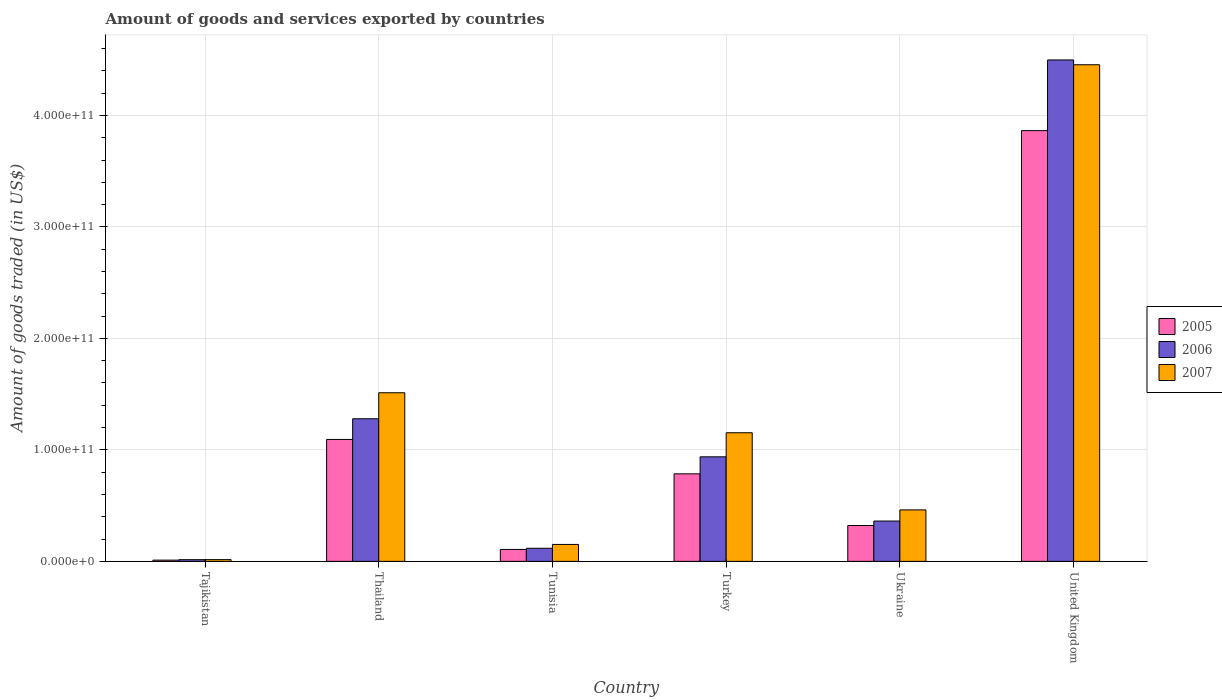How many different coloured bars are there?
Give a very brief answer. 3. How many groups of bars are there?
Keep it short and to the point. 6. Are the number of bars per tick equal to the number of legend labels?
Ensure brevity in your answer.  Yes. Are the number of bars on each tick of the X-axis equal?
Provide a succinct answer. Yes. What is the label of the 5th group of bars from the left?
Provide a short and direct response. Ukraine. In how many cases, is the number of bars for a given country not equal to the number of legend labels?
Make the answer very short. 0. What is the total amount of goods and services exported in 2005 in Tunisia?
Your answer should be compact. 1.07e+1. Across all countries, what is the maximum total amount of goods and services exported in 2007?
Your response must be concise. 4.45e+11. Across all countries, what is the minimum total amount of goods and services exported in 2005?
Offer a terse response. 1.11e+09. In which country was the total amount of goods and services exported in 2005 minimum?
Provide a succinct answer. Tajikistan. What is the total total amount of goods and services exported in 2006 in the graph?
Ensure brevity in your answer.  7.21e+11. What is the difference between the total amount of goods and services exported in 2007 in Turkey and that in United Kingdom?
Make the answer very short. -3.30e+11. What is the difference between the total amount of goods and services exported in 2006 in Thailand and the total amount of goods and services exported in 2007 in Turkey?
Keep it short and to the point. 1.26e+1. What is the average total amount of goods and services exported in 2005 per country?
Make the answer very short. 1.03e+11. What is the difference between the total amount of goods and services exported of/in 2006 and total amount of goods and services exported of/in 2005 in Turkey?
Provide a short and direct response. 1.53e+1. What is the ratio of the total amount of goods and services exported in 2005 in Tajikistan to that in Ukraine?
Your answer should be very brief. 0.03. Is the difference between the total amount of goods and services exported in 2006 in Thailand and Tunisia greater than the difference between the total amount of goods and services exported in 2005 in Thailand and Tunisia?
Offer a terse response. Yes. What is the difference between the highest and the second highest total amount of goods and services exported in 2005?
Ensure brevity in your answer.  3.08e+11. What is the difference between the highest and the lowest total amount of goods and services exported in 2005?
Keep it short and to the point. 3.85e+11. In how many countries, is the total amount of goods and services exported in 2005 greater than the average total amount of goods and services exported in 2005 taken over all countries?
Keep it short and to the point. 2. What does the 2nd bar from the left in Ukraine represents?
Give a very brief answer. 2006. What does the 3rd bar from the right in United Kingdom represents?
Ensure brevity in your answer.  2005. How many countries are there in the graph?
Your response must be concise. 6. What is the difference between two consecutive major ticks on the Y-axis?
Your answer should be very brief. 1.00e+11. Does the graph contain grids?
Give a very brief answer. Yes. How are the legend labels stacked?
Offer a terse response. Vertical. What is the title of the graph?
Your answer should be very brief. Amount of goods and services exported by countries. What is the label or title of the Y-axis?
Give a very brief answer. Amount of goods traded (in US$). What is the Amount of goods traded (in US$) of 2005 in Tajikistan?
Provide a succinct answer. 1.11e+09. What is the Amount of goods traded (in US$) of 2006 in Tajikistan?
Your answer should be very brief. 1.51e+09. What is the Amount of goods traded (in US$) in 2007 in Tajikistan?
Provide a short and direct response. 1.56e+09. What is the Amount of goods traded (in US$) in 2005 in Thailand?
Your answer should be very brief. 1.09e+11. What is the Amount of goods traded (in US$) of 2006 in Thailand?
Offer a very short reply. 1.28e+11. What is the Amount of goods traded (in US$) in 2007 in Thailand?
Ensure brevity in your answer.  1.51e+11. What is the Amount of goods traded (in US$) of 2005 in Tunisia?
Offer a terse response. 1.07e+1. What is the Amount of goods traded (in US$) in 2006 in Tunisia?
Make the answer very short. 1.17e+1. What is the Amount of goods traded (in US$) of 2007 in Tunisia?
Give a very brief answer. 1.52e+1. What is the Amount of goods traded (in US$) of 2005 in Turkey?
Provide a succinct answer. 7.85e+1. What is the Amount of goods traded (in US$) of 2006 in Turkey?
Keep it short and to the point. 9.38e+1. What is the Amount of goods traded (in US$) of 2007 in Turkey?
Provide a short and direct response. 1.15e+11. What is the Amount of goods traded (in US$) in 2005 in Ukraine?
Offer a very short reply. 3.22e+1. What is the Amount of goods traded (in US$) in 2006 in Ukraine?
Your response must be concise. 3.62e+1. What is the Amount of goods traded (in US$) of 2007 in Ukraine?
Offer a terse response. 4.62e+1. What is the Amount of goods traded (in US$) of 2005 in United Kingdom?
Make the answer very short. 3.86e+11. What is the Amount of goods traded (in US$) of 2006 in United Kingdom?
Keep it short and to the point. 4.50e+11. What is the Amount of goods traded (in US$) of 2007 in United Kingdom?
Offer a terse response. 4.45e+11. Across all countries, what is the maximum Amount of goods traded (in US$) in 2005?
Your response must be concise. 3.86e+11. Across all countries, what is the maximum Amount of goods traded (in US$) of 2006?
Your response must be concise. 4.50e+11. Across all countries, what is the maximum Amount of goods traded (in US$) of 2007?
Provide a short and direct response. 4.45e+11. Across all countries, what is the minimum Amount of goods traded (in US$) of 2005?
Provide a succinct answer. 1.11e+09. Across all countries, what is the minimum Amount of goods traded (in US$) of 2006?
Keep it short and to the point. 1.51e+09. Across all countries, what is the minimum Amount of goods traded (in US$) of 2007?
Make the answer very short. 1.56e+09. What is the total Amount of goods traded (in US$) in 2005 in the graph?
Your response must be concise. 6.18e+11. What is the total Amount of goods traded (in US$) of 2006 in the graph?
Provide a succinct answer. 7.21e+11. What is the total Amount of goods traded (in US$) of 2007 in the graph?
Ensure brevity in your answer.  7.75e+11. What is the difference between the Amount of goods traded (in US$) of 2005 in Tajikistan and that in Thailand?
Make the answer very short. -1.08e+11. What is the difference between the Amount of goods traded (in US$) of 2006 in Tajikistan and that in Thailand?
Provide a short and direct response. -1.26e+11. What is the difference between the Amount of goods traded (in US$) of 2007 in Tajikistan and that in Thailand?
Your response must be concise. -1.50e+11. What is the difference between the Amount of goods traded (in US$) of 2005 in Tajikistan and that in Tunisia?
Your answer should be compact. -9.58e+09. What is the difference between the Amount of goods traded (in US$) in 2006 in Tajikistan and that in Tunisia?
Your answer should be very brief. -1.02e+1. What is the difference between the Amount of goods traded (in US$) of 2007 in Tajikistan and that in Tunisia?
Your answer should be very brief. -1.36e+1. What is the difference between the Amount of goods traded (in US$) of 2005 in Tajikistan and that in Turkey?
Make the answer very short. -7.74e+1. What is the difference between the Amount of goods traded (in US$) in 2006 in Tajikistan and that in Turkey?
Your response must be concise. -9.23e+1. What is the difference between the Amount of goods traded (in US$) of 2007 in Tajikistan and that in Turkey?
Make the answer very short. -1.14e+11. What is the difference between the Amount of goods traded (in US$) of 2005 in Tajikistan and that in Ukraine?
Give a very brief answer. -3.11e+1. What is the difference between the Amount of goods traded (in US$) in 2006 in Tajikistan and that in Ukraine?
Make the answer very short. -3.47e+1. What is the difference between the Amount of goods traded (in US$) in 2007 in Tajikistan and that in Ukraine?
Provide a succinct answer. -4.46e+1. What is the difference between the Amount of goods traded (in US$) in 2005 in Tajikistan and that in United Kingdom?
Ensure brevity in your answer.  -3.85e+11. What is the difference between the Amount of goods traded (in US$) of 2006 in Tajikistan and that in United Kingdom?
Your answer should be compact. -4.48e+11. What is the difference between the Amount of goods traded (in US$) in 2007 in Tajikistan and that in United Kingdom?
Make the answer very short. -4.44e+11. What is the difference between the Amount of goods traded (in US$) in 2005 in Thailand and that in Tunisia?
Your answer should be compact. 9.87e+1. What is the difference between the Amount of goods traded (in US$) of 2006 in Thailand and that in Tunisia?
Provide a succinct answer. 1.16e+11. What is the difference between the Amount of goods traded (in US$) of 2007 in Thailand and that in Tunisia?
Ensure brevity in your answer.  1.36e+11. What is the difference between the Amount of goods traded (in US$) of 2005 in Thailand and that in Turkey?
Your answer should be very brief. 3.09e+1. What is the difference between the Amount of goods traded (in US$) in 2006 in Thailand and that in Turkey?
Offer a very short reply. 3.42e+1. What is the difference between the Amount of goods traded (in US$) in 2007 in Thailand and that in Turkey?
Your response must be concise. 3.59e+1. What is the difference between the Amount of goods traded (in US$) of 2005 in Thailand and that in Ukraine?
Your answer should be very brief. 7.72e+1. What is the difference between the Amount of goods traded (in US$) in 2006 in Thailand and that in Ukraine?
Provide a short and direct response. 9.18e+1. What is the difference between the Amount of goods traded (in US$) of 2007 in Thailand and that in Ukraine?
Make the answer very short. 1.05e+11. What is the difference between the Amount of goods traded (in US$) in 2005 in Thailand and that in United Kingdom?
Offer a terse response. -2.77e+11. What is the difference between the Amount of goods traded (in US$) of 2006 in Thailand and that in United Kingdom?
Keep it short and to the point. -3.22e+11. What is the difference between the Amount of goods traded (in US$) in 2007 in Thailand and that in United Kingdom?
Provide a succinct answer. -2.94e+11. What is the difference between the Amount of goods traded (in US$) of 2005 in Tunisia and that in Turkey?
Your response must be concise. -6.78e+1. What is the difference between the Amount of goods traded (in US$) in 2006 in Tunisia and that in Turkey?
Provide a short and direct response. -8.20e+1. What is the difference between the Amount of goods traded (in US$) of 2007 in Tunisia and that in Turkey?
Offer a very short reply. -1.00e+11. What is the difference between the Amount of goods traded (in US$) in 2005 in Tunisia and that in Ukraine?
Your answer should be compact. -2.15e+1. What is the difference between the Amount of goods traded (in US$) in 2006 in Tunisia and that in Ukraine?
Give a very brief answer. -2.44e+1. What is the difference between the Amount of goods traded (in US$) of 2007 in Tunisia and that in Ukraine?
Give a very brief answer. -3.10e+1. What is the difference between the Amount of goods traded (in US$) of 2005 in Tunisia and that in United Kingdom?
Make the answer very short. -3.76e+11. What is the difference between the Amount of goods traded (in US$) in 2006 in Tunisia and that in United Kingdom?
Provide a succinct answer. -4.38e+11. What is the difference between the Amount of goods traded (in US$) of 2007 in Tunisia and that in United Kingdom?
Make the answer very short. -4.30e+11. What is the difference between the Amount of goods traded (in US$) of 2005 in Turkey and that in Ukraine?
Ensure brevity in your answer.  4.63e+1. What is the difference between the Amount of goods traded (in US$) of 2006 in Turkey and that in Ukraine?
Your answer should be very brief. 5.76e+1. What is the difference between the Amount of goods traded (in US$) of 2007 in Turkey and that in Ukraine?
Give a very brief answer. 6.92e+1. What is the difference between the Amount of goods traded (in US$) in 2005 in Turkey and that in United Kingdom?
Provide a short and direct response. -3.08e+11. What is the difference between the Amount of goods traded (in US$) of 2006 in Turkey and that in United Kingdom?
Provide a succinct answer. -3.56e+11. What is the difference between the Amount of goods traded (in US$) in 2007 in Turkey and that in United Kingdom?
Provide a short and direct response. -3.30e+11. What is the difference between the Amount of goods traded (in US$) in 2005 in Ukraine and that in United Kingdom?
Provide a short and direct response. -3.54e+11. What is the difference between the Amount of goods traded (in US$) of 2006 in Ukraine and that in United Kingdom?
Ensure brevity in your answer.  -4.14e+11. What is the difference between the Amount of goods traded (in US$) of 2007 in Ukraine and that in United Kingdom?
Make the answer very short. -3.99e+11. What is the difference between the Amount of goods traded (in US$) in 2005 in Tajikistan and the Amount of goods traded (in US$) in 2006 in Thailand?
Offer a terse response. -1.27e+11. What is the difference between the Amount of goods traded (in US$) in 2005 in Tajikistan and the Amount of goods traded (in US$) in 2007 in Thailand?
Keep it short and to the point. -1.50e+11. What is the difference between the Amount of goods traded (in US$) in 2006 in Tajikistan and the Amount of goods traded (in US$) in 2007 in Thailand?
Make the answer very short. -1.50e+11. What is the difference between the Amount of goods traded (in US$) in 2005 in Tajikistan and the Amount of goods traded (in US$) in 2006 in Tunisia?
Keep it short and to the point. -1.06e+1. What is the difference between the Amount of goods traded (in US$) in 2005 in Tajikistan and the Amount of goods traded (in US$) in 2007 in Tunisia?
Your answer should be very brief. -1.41e+1. What is the difference between the Amount of goods traded (in US$) of 2006 in Tajikistan and the Amount of goods traded (in US$) of 2007 in Tunisia?
Give a very brief answer. -1.37e+1. What is the difference between the Amount of goods traded (in US$) in 2005 in Tajikistan and the Amount of goods traded (in US$) in 2006 in Turkey?
Provide a short and direct response. -9.27e+1. What is the difference between the Amount of goods traded (in US$) of 2005 in Tajikistan and the Amount of goods traded (in US$) of 2007 in Turkey?
Keep it short and to the point. -1.14e+11. What is the difference between the Amount of goods traded (in US$) of 2006 in Tajikistan and the Amount of goods traded (in US$) of 2007 in Turkey?
Provide a succinct answer. -1.14e+11. What is the difference between the Amount of goods traded (in US$) of 2005 in Tajikistan and the Amount of goods traded (in US$) of 2006 in Ukraine?
Provide a succinct answer. -3.51e+1. What is the difference between the Amount of goods traded (in US$) in 2005 in Tajikistan and the Amount of goods traded (in US$) in 2007 in Ukraine?
Keep it short and to the point. -4.51e+1. What is the difference between the Amount of goods traded (in US$) in 2006 in Tajikistan and the Amount of goods traded (in US$) in 2007 in Ukraine?
Give a very brief answer. -4.47e+1. What is the difference between the Amount of goods traded (in US$) in 2005 in Tajikistan and the Amount of goods traded (in US$) in 2006 in United Kingdom?
Offer a very short reply. -4.49e+11. What is the difference between the Amount of goods traded (in US$) of 2005 in Tajikistan and the Amount of goods traded (in US$) of 2007 in United Kingdom?
Provide a short and direct response. -4.44e+11. What is the difference between the Amount of goods traded (in US$) of 2006 in Tajikistan and the Amount of goods traded (in US$) of 2007 in United Kingdom?
Offer a very short reply. -4.44e+11. What is the difference between the Amount of goods traded (in US$) of 2005 in Thailand and the Amount of goods traded (in US$) of 2006 in Tunisia?
Offer a very short reply. 9.76e+1. What is the difference between the Amount of goods traded (in US$) in 2005 in Thailand and the Amount of goods traded (in US$) in 2007 in Tunisia?
Provide a succinct answer. 9.42e+1. What is the difference between the Amount of goods traded (in US$) in 2006 in Thailand and the Amount of goods traded (in US$) in 2007 in Tunisia?
Your answer should be compact. 1.13e+11. What is the difference between the Amount of goods traded (in US$) of 2005 in Thailand and the Amount of goods traded (in US$) of 2006 in Turkey?
Offer a very short reply. 1.56e+1. What is the difference between the Amount of goods traded (in US$) in 2005 in Thailand and the Amount of goods traded (in US$) in 2007 in Turkey?
Provide a succinct answer. -6.01e+09. What is the difference between the Amount of goods traded (in US$) of 2006 in Thailand and the Amount of goods traded (in US$) of 2007 in Turkey?
Your answer should be very brief. 1.26e+1. What is the difference between the Amount of goods traded (in US$) of 2005 in Thailand and the Amount of goods traded (in US$) of 2006 in Ukraine?
Offer a terse response. 7.32e+1. What is the difference between the Amount of goods traded (in US$) in 2005 in Thailand and the Amount of goods traded (in US$) in 2007 in Ukraine?
Your response must be concise. 6.32e+1. What is the difference between the Amount of goods traded (in US$) in 2006 in Thailand and the Amount of goods traded (in US$) in 2007 in Ukraine?
Make the answer very short. 8.18e+1. What is the difference between the Amount of goods traded (in US$) of 2005 in Thailand and the Amount of goods traded (in US$) of 2006 in United Kingdom?
Provide a succinct answer. -3.40e+11. What is the difference between the Amount of goods traded (in US$) of 2005 in Thailand and the Amount of goods traded (in US$) of 2007 in United Kingdom?
Make the answer very short. -3.36e+11. What is the difference between the Amount of goods traded (in US$) in 2006 in Thailand and the Amount of goods traded (in US$) in 2007 in United Kingdom?
Provide a succinct answer. -3.18e+11. What is the difference between the Amount of goods traded (in US$) in 2005 in Tunisia and the Amount of goods traded (in US$) in 2006 in Turkey?
Your answer should be compact. -8.31e+1. What is the difference between the Amount of goods traded (in US$) in 2005 in Tunisia and the Amount of goods traded (in US$) in 2007 in Turkey?
Your response must be concise. -1.05e+11. What is the difference between the Amount of goods traded (in US$) in 2006 in Tunisia and the Amount of goods traded (in US$) in 2007 in Turkey?
Offer a very short reply. -1.04e+11. What is the difference between the Amount of goods traded (in US$) in 2005 in Tunisia and the Amount of goods traded (in US$) in 2006 in Ukraine?
Your response must be concise. -2.55e+1. What is the difference between the Amount of goods traded (in US$) of 2005 in Tunisia and the Amount of goods traded (in US$) of 2007 in Ukraine?
Give a very brief answer. -3.55e+1. What is the difference between the Amount of goods traded (in US$) in 2006 in Tunisia and the Amount of goods traded (in US$) in 2007 in Ukraine?
Offer a very short reply. -3.44e+1. What is the difference between the Amount of goods traded (in US$) in 2005 in Tunisia and the Amount of goods traded (in US$) in 2006 in United Kingdom?
Your answer should be very brief. -4.39e+11. What is the difference between the Amount of goods traded (in US$) of 2005 in Tunisia and the Amount of goods traded (in US$) of 2007 in United Kingdom?
Your answer should be very brief. -4.35e+11. What is the difference between the Amount of goods traded (in US$) in 2006 in Tunisia and the Amount of goods traded (in US$) in 2007 in United Kingdom?
Offer a terse response. -4.34e+11. What is the difference between the Amount of goods traded (in US$) in 2005 in Turkey and the Amount of goods traded (in US$) in 2006 in Ukraine?
Your response must be concise. 4.23e+1. What is the difference between the Amount of goods traded (in US$) in 2005 in Turkey and the Amount of goods traded (in US$) in 2007 in Ukraine?
Offer a terse response. 3.23e+1. What is the difference between the Amount of goods traded (in US$) in 2006 in Turkey and the Amount of goods traded (in US$) in 2007 in Ukraine?
Give a very brief answer. 4.76e+1. What is the difference between the Amount of goods traded (in US$) in 2005 in Turkey and the Amount of goods traded (in US$) in 2006 in United Kingdom?
Make the answer very short. -3.71e+11. What is the difference between the Amount of goods traded (in US$) in 2005 in Turkey and the Amount of goods traded (in US$) in 2007 in United Kingdom?
Ensure brevity in your answer.  -3.67e+11. What is the difference between the Amount of goods traded (in US$) of 2006 in Turkey and the Amount of goods traded (in US$) of 2007 in United Kingdom?
Ensure brevity in your answer.  -3.52e+11. What is the difference between the Amount of goods traded (in US$) in 2005 in Ukraine and the Amount of goods traded (in US$) in 2006 in United Kingdom?
Keep it short and to the point. -4.18e+11. What is the difference between the Amount of goods traded (in US$) of 2005 in Ukraine and the Amount of goods traded (in US$) of 2007 in United Kingdom?
Provide a short and direct response. -4.13e+11. What is the difference between the Amount of goods traded (in US$) of 2006 in Ukraine and the Amount of goods traded (in US$) of 2007 in United Kingdom?
Provide a succinct answer. -4.09e+11. What is the average Amount of goods traded (in US$) of 2005 per country?
Keep it short and to the point. 1.03e+11. What is the average Amount of goods traded (in US$) in 2006 per country?
Offer a terse response. 1.20e+11. What is the average Amount of goods traded (in US$) in 2007 per country?
Offer a very short reply. 1.29e+11. What is the difference between the Amount of goods traded (in US$) in 2005 and Amount of goods traded (in US$) in 2006 in Tajikistan?
Ensure brevity in your answer.  -4.04e+08. What is the difference between the Amount of goods traded (in US$) in 2005 and Amount of goods traded (in US$) in 2007 in Tajikistan?
Your response must be concise. -4.49e+08. What is the difference between the Amount of goods traded (in US$) in 2006 and Amount of goods traded (in US$) in 2007 in Tajikistan?
Your response must be concise. -4.51e+07. What is the difference between the Amount of goods traded (in US$) of 2005 and Amount of goods traded (in US$) of 2006 in Thailand?
Your answer should be compact. -1.86e+1. What is the difference between the Amount of goods traded (in US$) in 2005 and Amount of goods traded (in US$) in 2007 in Thailand?
Keep it short and to the point. -4.19e+1. What is the difference between the Amount of goods traded (in US$) in 2006 and Amount of goods traded (in US$) in 2007 in Thailand?
Provide a succinct answer. -2.33e+1. What is the difference between the Amount of goods traded (in US$) in 2005 and Amount of goods traded (in US$) in 2006 in Tunisia?
Your response must be concise. -1.05e+09. What is the difference between the Amount of goods traded (in US$) in 2005 and Amount of goods traded (in US$) in 2007 in Tunisia?
Make the answer very short. -4.50e+09. What is the difference between the Amount of goods traded (in US$) in 2006 and Amount of goods traded (in US$) in 2007 in Tunisia?
Make the answer very short. -3.45e+09. What is the difference between the Amount of goods traded (in US$) of 2005 and Amount of goods traded (in US$) of 2006 in Turkey?
Provide a short and direct response. -1.53e+1. What is the difference between the Amount of goods traded (in US$) of 2005 and Amount of goods traded (in US$) of 2007 in Turkey?
Offer a very short reply. -3.69e+1. What is the difference between the Amount of goods traded (in US$) in 2006 and Amount of goods traded (in US$) in 2007 in Turkey?
Offer a very short reply. -2.16e+1. What is the difference between the Amount of goods traded (in US$) of 2005 and Amount of goods traded (in US$) of 2006 in Ukraine?
Provide a short and direct response. -3.99e+09. What is the difference between the Amount of goods traded (in US$) of 2005 and Amount of goods traded (in US$) of 2007 in Ukraine?
Keep it short and to the point. -1.40e+1. What is the difference between the Amount of goods traded (in US$) in 2006 and Amount of goods traded (in US$) in 2007 in Ukraine?
Your answer should be very brief. -9.99e+09. What is the difference between the Amount of goods traded (in US$) of 2005 and Amount of goods traded (in US$) of 2006 in United Kingdom?
Make the answer very short. -6.34e+1. What is the difference between the Amount of goods traded (in US$) in 2005 and Amount of goods traded (in US$) in 2007 in United Kingdom?
Provide a succinct answer. -5.91e+1. What is the difference between the Amount of goods traded (in US$) in 2006 and Amount of goods traded (in US$) in 2007 in United Kingdom?
Make the answer very short. 4.31e+09. What is the ratio of the Amount of goods traded (in US$) of 2005 in Tajikistan to that in Thailand?
Your answer should be very brief. 0.01. What is the ratio of the Amount of goods traded (in US$) of 2006 in Tajikistan to that in Thailand?
Provide a short and direct response. 0.01. What is the ratio of the Amount of goods traded (in US$) of 2007 in Tajikistan to that in Thailand?
Keep it short and to the point. 0.01. What is the ratio of the Amount of goods traded (in US$) in 2005 in Tajikistan to that in Tunisia?
Your answer should be compact. 0.1. What is the ratio of the Amount of goods traded (in US$) of 2006 in Tajikistan to that in Tunisia?
Keep it short and to the point. 0.13. What is the ratio of the Amount of goods traded (in US$) of 2007 in Tajikistan to that in Tunisia?
Make the answer very short. 0.1. What is the ratio of the Amount of goods traded (in US$) of 2005 in Tajikistan to that in Turkey?
Give a very brief answer. 0.01. What is the ratio of the Amount of goods traded (in US$) of 2006 in Tajikistan to that in Turkey?
Make the answer very short. 0.02. What is the ratio of the Amount of goods traded (in US$) in 2007 in Tajikistan to that in Turkey?
Offer a terse response. 0.01. What is the ratio of the Amount of goods traded (in US$) of 2005 in Tajikistan to that in Ukraine?
Offer a terse response. 0.03. What is the ratio of the Amount of goods traded (in US$) of 2006 in Tajikistan to that in Ukraine?
Ensure brevity in your answer.  0.04. What is the ratio of the Amount of goods traded (in US$) in 2007 in Tajikistan to that in Ukraine?
Keep it short and to the point. 0.03. What is the ratio of the Amount of goods traded (in US$) of 2005 in Tajikistan to that in United Kingdom?
Your answer should be compact. 0. What is the ratio of the Amount of goods traded (in US$) in 2006 in Tajikistan to that in United Kingdom?
Keep it short and to the point. 0. What is the ratio of the Amount of goods traded (in US$) in 2007 in Tajikistan to that in United Kingdom?
Your response must be concise. 0. What is the ratio of the Amount of goods traded (in US$) in 2005 in Thailand to that in Tunisia?
Provide a succinct answer. 10.23. What is the ratio of the Amount of goods traded (in US$) of 2006 in Thailand to that in Tunisia?
Keep it short and to the point. 10.9. What is the ratio of the Amount of goods traded (in US$) of 2007 in Thailand to that in Tunisia?
Your response must be concise. 9.96. What is the ratio of the Amount of goods traded (in US$) of 2005 in Thailand to that in Turkey?
Provide a succinct answer. 1.39. What is the ratio of the Amount of goods traded (in US$) of 2006 in Thailand to that in Turkey?
Your answer should be very brief. 1.36. What is the ratio of the Amount of goods traded (in US$) of 2007 in Thailand to that in Turkey?
Your answer should be compact. 1.31. What is the ratio of the Amount of goods traded (in US$) of 2005 in Thailand to that in Ukraine?
Provide a succinct answer. 3.4. What is the ratio of the Amount of goods traded (in US$) of 2006 in Thailand to that in Ukraine?
Provide a succinct answer. 3.54. What is the ratio of the Amount of goods traded (in US$) of 2007 in Thailand to that in Ukraine?
Provide a short and direct response. 3.28. What is the ratio of the Amount of goods traded (in US$) of 2005 in Thailand to that in United Kingdom?
Ensure brevity in your answer.  0.28. What is the ratio of the Amount of goods traded (in US$) of 2006 in Thailand to that in United Kingdom?
Make the answer very short. 0.28. What is the ratio of the Amount of goods traded (in US$) in 2007 in Thailand to that in United Kingdom?
Make the answer very short. 0.34. What is the ratio of the Amount of goods traded (in US$) of 2005 in Tunisia to that in Turkey?
Your response must be concise. 0.14. What is the ratio of the Amount of goods traded (in US$) of 2006 in Tunisia to that in Turkey?
Your answer should be compact. 0.13. What is the ratio of the Amount of goods traded (in US$) of 2007 in Tunisia to that in Turkey?
Provide a short and direct response. 0.13. What is the ratio of the Amount of goods traded (in US$) of 2005 in Tunisia to that in Ukraine?
Your response must be concise. 0.33. What is the ratio of the Amount of goods traded (in US$) of 2006 in Tunisia to that in Ukraine?
Your answer should be compact. 0.32. What is the ratio of the Amount of goods traded (in US$) of 2007 in Tunisia to that in Ukraine?
Provide a short and direct response. 0.33. What is the ratio of the Amount of goods traded (in US$) in 2005 in Tunisia to that in United Kingdom?
Offer a very short reply. 0.03. What is the ratio of the Amount of goods traded (in US$) in 2006 in Tunisia to that in United Kingdom?
Your answer should be compact. 0.03. What is the ratio of the Amount of goods traded (in US$) of 2007 in Tunisia to that in United Kingdom?
Your response must be concise. 0.03. What is the ratio of the Amount of goods traded (in US$) of 2005 in Turkey to that in Ukraine?
Your answer should be very brief. 2.44. What is the ratio of the Amount of goods traded (in US$) of 2006 in Turkey to that in Ukraine?
Keep it short and to the point. 2.59. What is the ratio of the Amount of goods traded (in US$) in 2007 in Turkey to that in Ukraine?
Provide a succinct answer. 2.5. What is the ratio of the Amount of goods traded (in US$) of 2005 in Turkey to that in United Kingdom?
Give a very brief answer. 0.2. What is the ratio of the Amount of goods traded (in US$) in 2006 in Turkey to that in United Kingdom?
Offer a terse response. 0.21. What is the ratio of the Amount of goods traded (in US$) in 2007 in Turkey to that in United Kingdom?
Your response must be concise. 0.26. What is the ratio of the Amount of goods traded (in US$) in 2005 in Ukraine to that in United Kingdom?
Offer a terse response. 0.08. What is the ratio of the Amount of goods traded (in US$) of 2006 in Ukraine to that in United Kingdom?
Give a very brief answer. 0.08. What is the ratio of the Amount of goods traded (in US$) of 2007 in Ukraine to that in United Kingdom?
Offer a very short reply. 0.1. What is the difference between the highest and the second highest Amount of goods traded (in US$) in 2005?
Your answer should be very brief. 2.77e+11. What is the difference between the highest and the second highest Amount of goods traded (in US$) in 2006?
Your answer should be very brief. 3.22e+11. What is the difference between the highest and the second highest Amount of goods traded (in US$) in 2007?
Give a very brief answer. 2.94e+11. What is the difference between the highest and the lowest Amount of goods traded (in US$) of 2005?
Provide a short and direct response. 3.85e+11. What is the difference between the highest and the lowest Amount of goods traded (in US$) in 2006?
Your answer should be compact. 4.48e+11. What is the difference between the highest and the lowest Amount of goods traded (in US$) in 2007?
Offer a very short reply. 4.44e+11. 